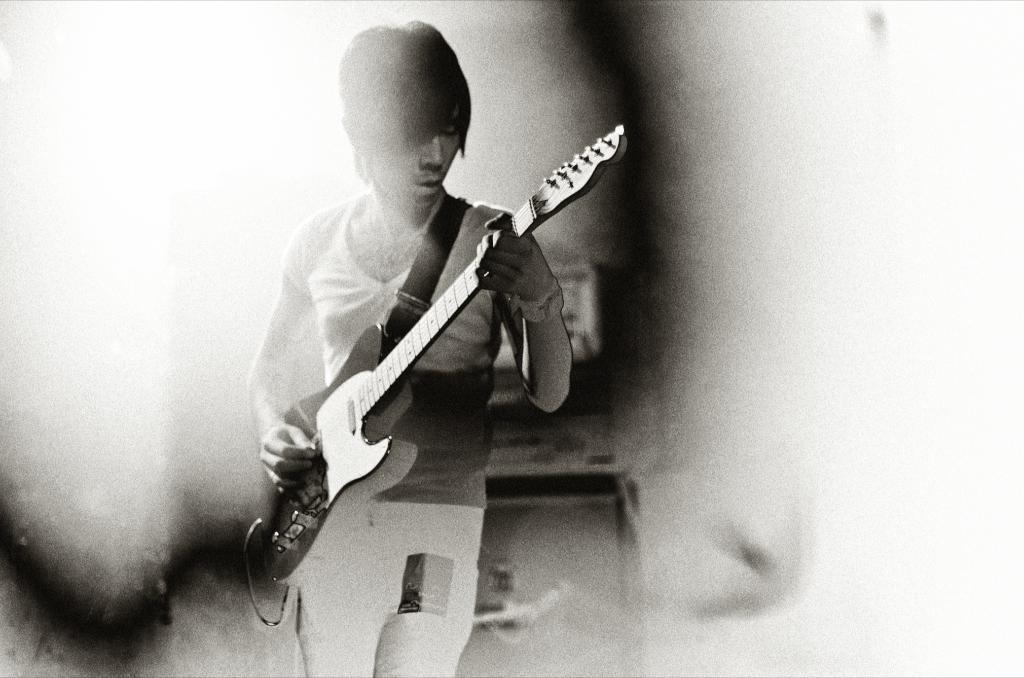How would you summarize this image in a sentence or two? In this image, in the middle there is a boy he is standing and holding a music instrument which is in black color. 